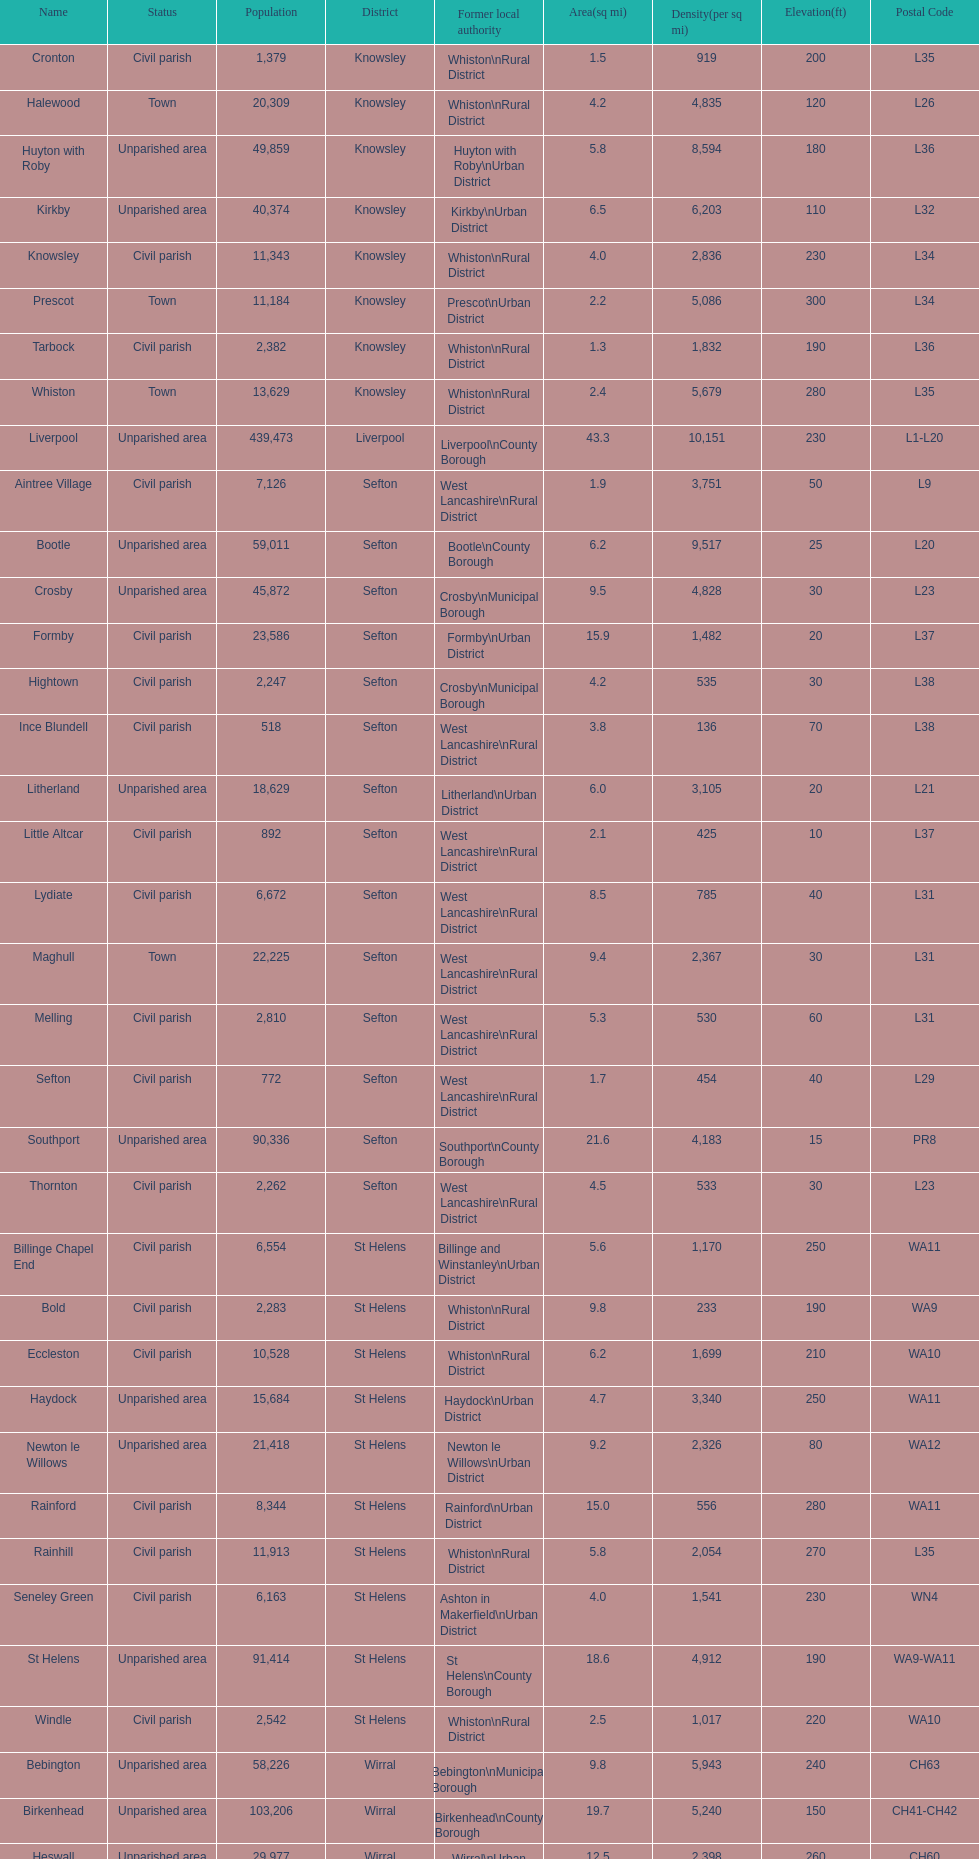What is the largest area in terms of population? Liverpool. 